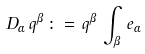<formula> <loc_0><loc_0><loc_500><loc_500>D _ { \alpha } \, q ^ { \beta } \, \colon = \, q ^ { \beta } \, \int _ { \beta } \, e _ { \alpha }</formula> 